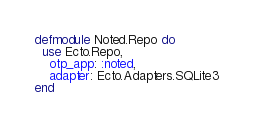<code> <loc_0><loc_0><loc_500><loc_500><_Elixir_>defmodule Noted.Repo do
  use Ecto.Repo,
    otp_app: :noted,
    adapter: Ecto.Adapters.SQLite3
end
</code> 